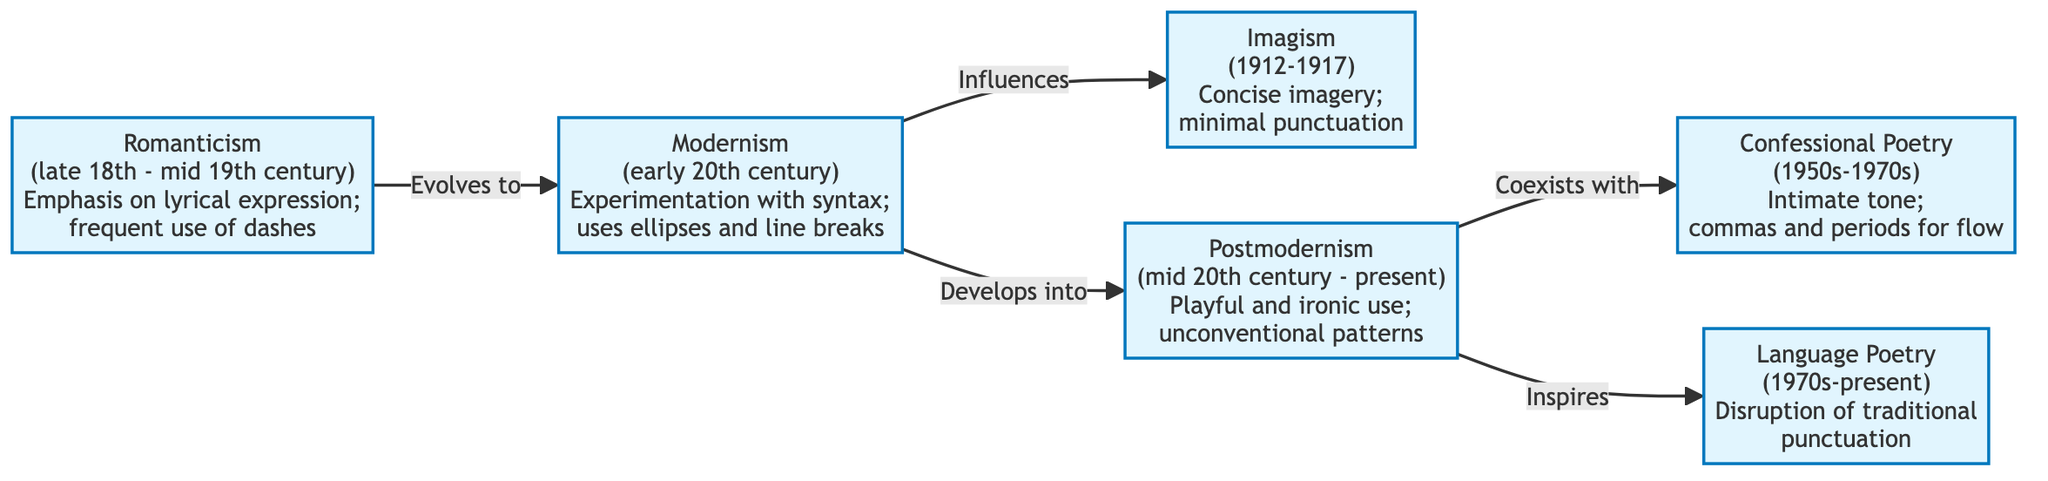What literary movement is associated with the use of dashes for emotional pauses? The diagram lists "Romanticism" as having frequent use of dashes for emotional pauses, indicating that this movement is associated with this punctuation practice.
Answer: Romanticism How many literary movements are represented in the diagram? The diagram lists six distinct literary movements, corresponding to each node, which accounts for the total number of movements represented.
Answer: 6 Which movement coexists with Postmodernism? The diagram describes a coexistence between "Postmodernism" and "Confessional Poetry," indicating that these two movements exist simultaneously.
Answer: Confessional Poetry What punctuation practice is utilized in Imagism? The diagram states that Imagism has a "preference for minimal punctuation" to enhance visual clarity, which directly identifies the punctuation practice linked to this movement.
Answer: Minimal punctuation What is the direct influence of Modernism on Imagism? The diagram shows a directional arrow labeled "Influences" from "Modernism" to "Imagism," signifying that Modernism has a direct impact or influence on the practices of Imagism.
Answer: Influences How does the punctuation practice of Confessional Poetry primarily affect its tone? The diagram indicates that Confessional Poetry uses "commas and periods to create a conversational flow," suggesting that this practice affects the tone by making it more intimate and flowing.
Answer: Conversational flow Which movement is known for experimenting with syntax using ellipses and line breaks? The diagram specifies "Modernism" as the movement that experiments with syntax and uses ellipses and line breaks to create fragmentation, clearly identifying it as the associated movement.
Answer: Modernism What literary movement follows Romanticism in the timeline? According to the diagram, the directional flow shows an arrow from "Romanticism" to "Modernism," indicating that Modernism is the subsequent movement in the timeline after Romanticism.
Answer: Modernism What unique approach does Language Poetry take towards traditional punctuation? The diagram details that Language Poetry involves a "disruption of traditional punctuation," indicating a challenge to conventional norms of punctuation within the poetry of this movement.
Answer: Disruption of traditional punctuation 